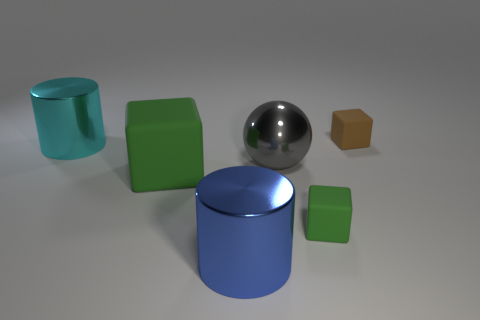Subtract all tiny matte cubes. How many cubes are left? 1 Subtract 1 balls. How many balls are left? 0 Add 2 tiny purple metal spheres. How many objects exist? 8 Subtract all brown cubes. How many cubes are left? 2 Subtract all balls. How many objects are left? 5 Subtract all cyan balls. How many green cubes are left? 2 Subtract 0 brown cylinders. How many objects are left? 6 Subtract all gray cylinders. Subtract all blue spheres. How many cylinders are left? 2 Subtract all big cyan metal cylinders. Subtract all brown matte blocks. How many objects are left? 4 Add 1 blue objects. How many blue objects are left? 2 